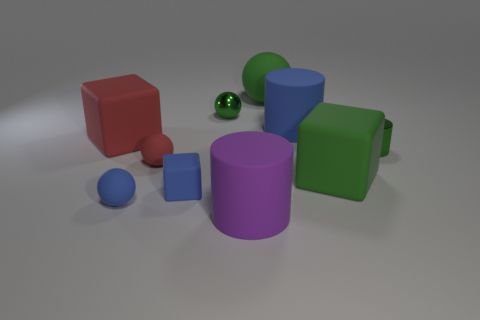Subtract 1 spheres. How many spheres are left? 3 Subtract all cyan cubes. Subtract all cyan spheres. How many cubes are left? 3 Subtract all spheres. How many objects are left? 6 Add 8 small green metal things. How many small green metal things are left? 10 Add 7 green metallic objects. How many green metallic objects exist? 9 Subtract 1 blue blocks. How many objects are left? 9 Subtract all large rubber balls. Subtract all small green metal things. How many objects are left? 7 